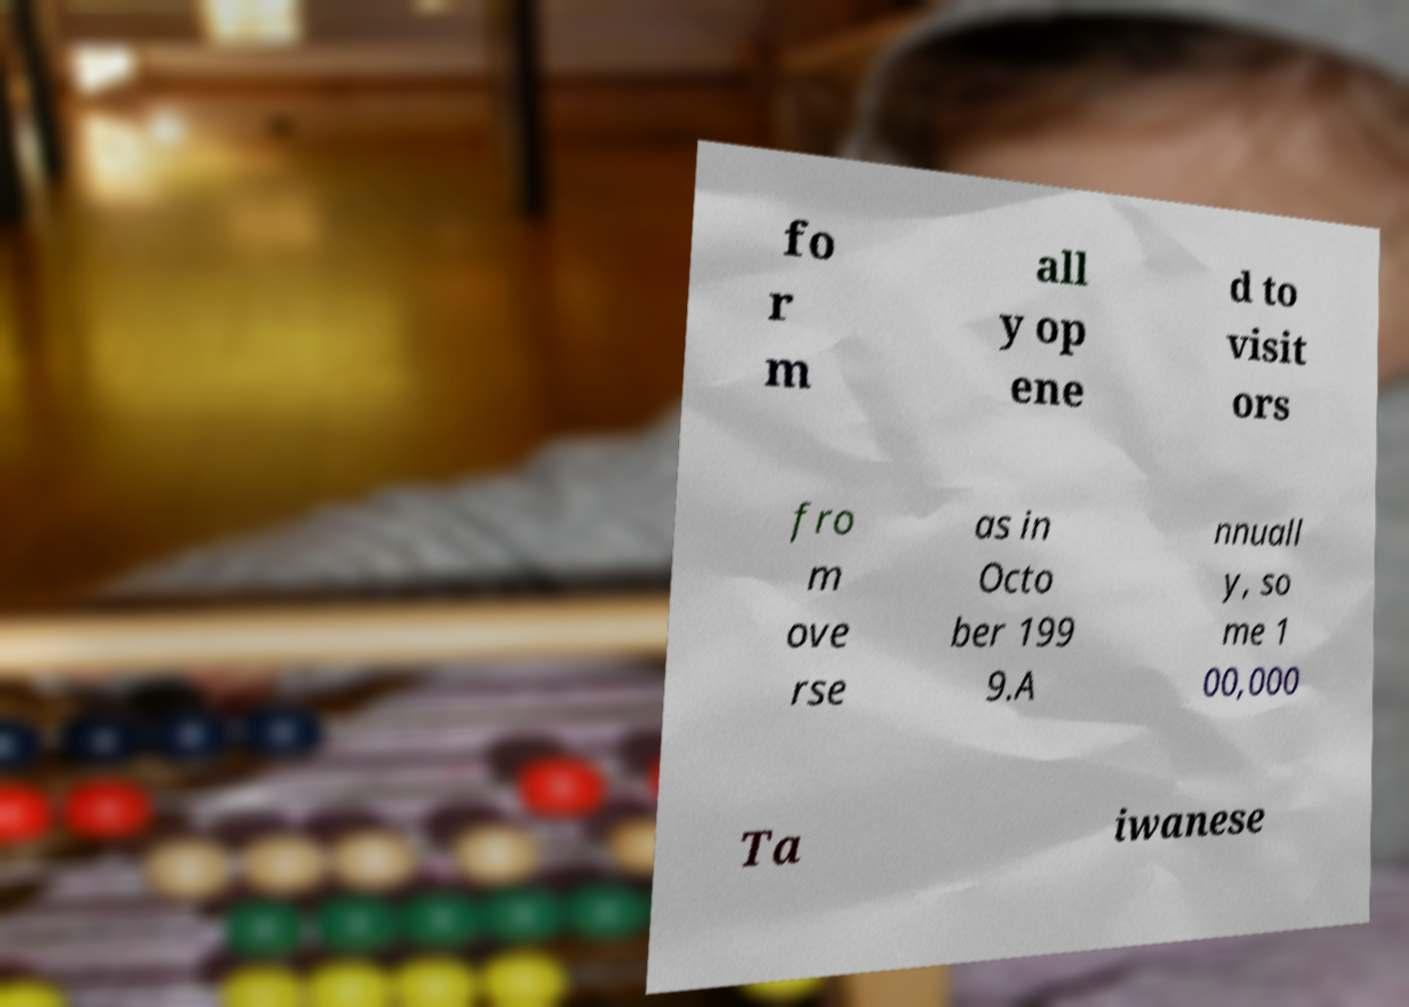There's text embedded in this image that I need extracted. Can you transcribe it verbatim? fo r m all y op ene d to visit ors fro m ove rse as in Octo ber 199 9.A nnuall y, so me 1 00,000 Ta iwanese 